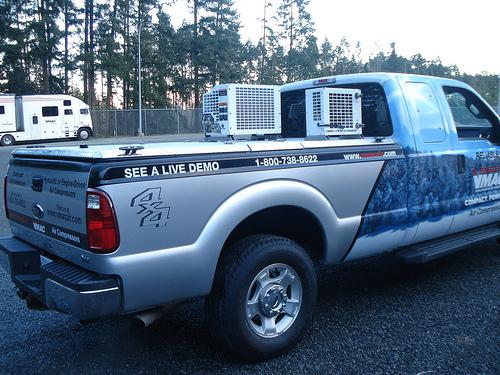Question: who drives the truck?
Choices:
A. Woman.
B. Man.
C. Old man.
D. Old woman.
Answer with the letter. Answer: B Question: what is white?
Choices:
A. Motor home to the left.
B. Motor home to the right.
C. Motor home to the south.
D. Motor home to the north.
Answer with the letter. Answer: A Question: why is there a reflection on the window?
Choices:
A. Lightbulb.
B. Sunlight.
C. Flashlight.
D. Flash from camera.
Answer with the letter. Answer: B Question: what is silver?
Choices:
A. Truck.
B. Mailbox.
C. Bike.
D. Skateboard.
Answer with the letter. Answer: A Question: what is black?
Choices:
A. Bike wheels.
B. Pavement.
C. Mailbox.
D. Tires.
Answer with the letter. Answer: D Question: where are the trees?
Choices:
A. In the forest.
B. Next to the house.
C. Behind the mailbox.
D. Behind a motorhome.
Answer with the letter. Answer: D 